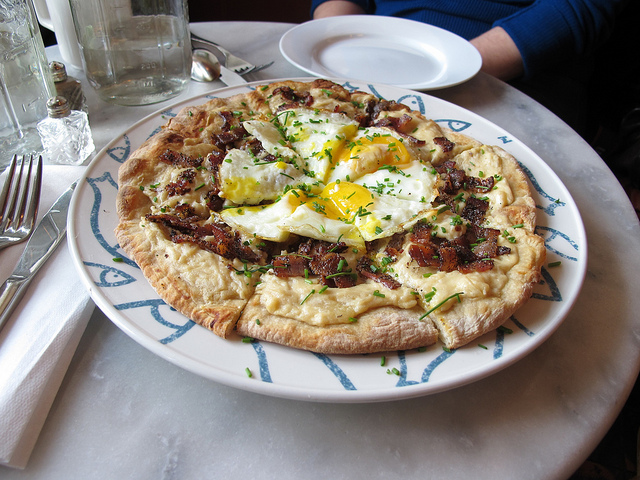<image>What kind of food is on the plate? I don't know exactly what food is on the plate. It could be pizza or tarte flambee. What kind of food is on the plate? It is unclear what kind of food is on the plate. It can be pizza or tarte flambee. 